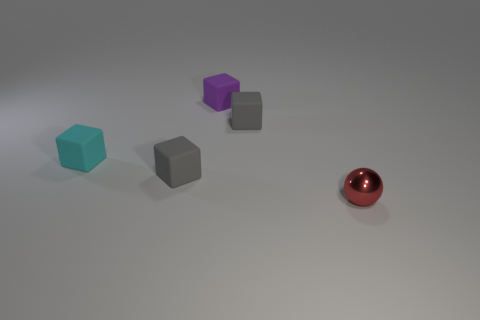What number of objects are small purple matte balls or tiny blocks?
Ensure brevity in your answer.  4. What is the shape of the purple thing that is made of the same material as the small cyan thing?
Make the answer very short. Cube. What number of tiny things are either cyan matte cubes or spheres?
Provide a succinct answer. 2. How many other things are the same color as the small metal ball?
Make the answer very short. 0. There is a gray rubber object that is in front of the matte block that is to the right of the small purple matte cube; how many purple rubber cubes are in front of it?
Provide a short and direct response. 0. There is a gray object in front of the cyan rubber object; does it have the same size as the sphere?
Keep it short and to the point. Yes. Are there fewer tiny cyan cubes that are right of the cyan rubber block than small gray rubber blocks that are behind the purple matte block?
Keep it short and to the point. No. Is the number of small gray cubes left of the small cyan block less than the number of tiny cyan cubes?
Make the answer very short. Yes. Does the small purple thing have the same material as the cyan block?
Provide a succinct answer. Yes. How many small purple objects are made of the same material as the cyan block?
Provide a succinct answer. 1. 